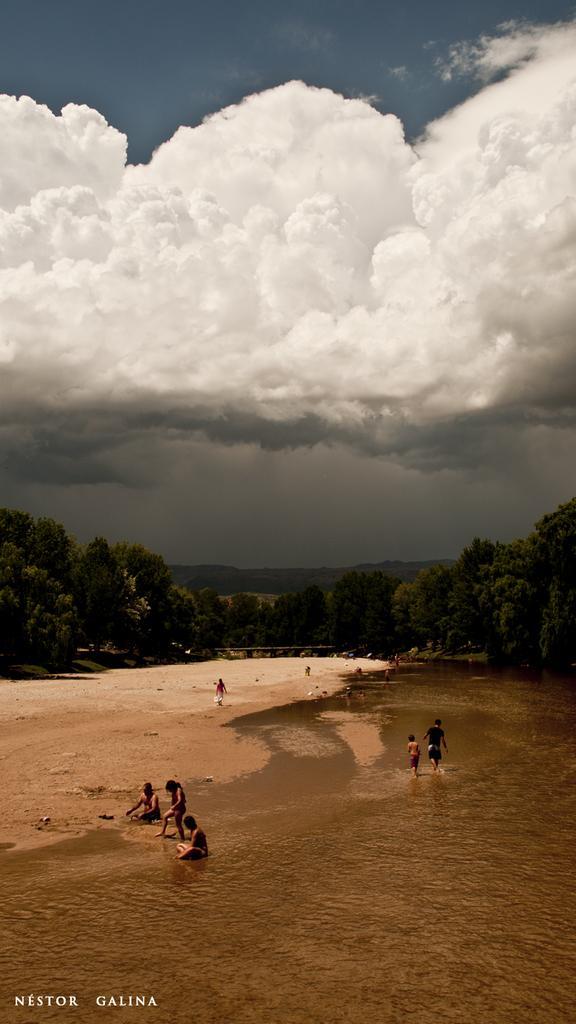How would you summarize this image in a sentence or two? In this image, we can see some water. There are a few people. We can see the ground. There are a few trees. We can see some hills and the sky with clouds. 